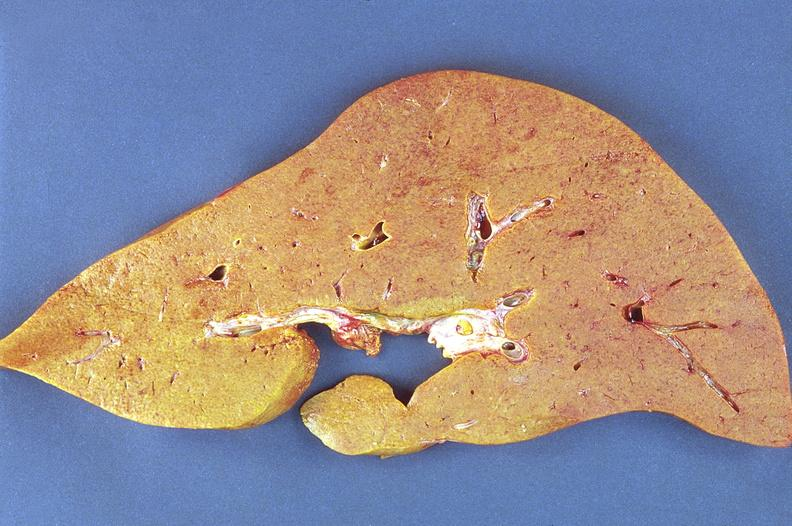what does this image show?
Answer the question using a single word or phrase. Amyloidosis 